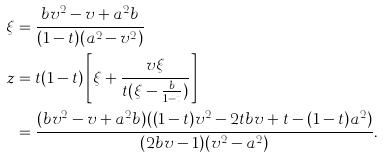Convert formula to latex. <formula><loc_0><loc_0><loc_500><loc_500>\xi & = \frac { b v ^ { 2 } - v + a ^ { 2 } b } { ( 1 - t ) ( a ^ { 2 } - v ^ { 2 } ) } \\ z & = t ( 1 - t ) \left [ \xi + \frac { v \xi } { t ( \xi - \frac { b } { 1 - t } ) } \right ] \\ & = \frac { ( b v ^ { 2 } - v + a ^ { 2 } b ) ( ( 1 - t ) v ^ { 2 } - 2 t b v + t - ( 1 - t ) a ^ { 2 } ) } { ( 2 b v - 1 ) ( v ^ { 2 } - a ^ { 2 } ) } .</formula> 